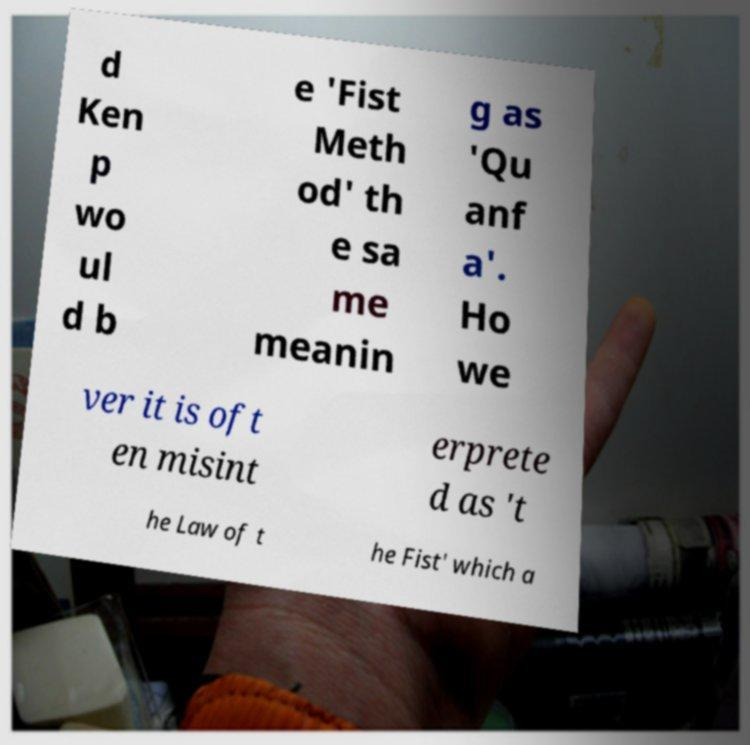Can you accurately transcribe the text from the provided image for me? d Ken p wo ul d b e 'Fist Meth od' th e sa me meanin g as 'Qu anf a'. Ho we ver it is oft en misint erprete d as 't he Law of t he Fist' which a 